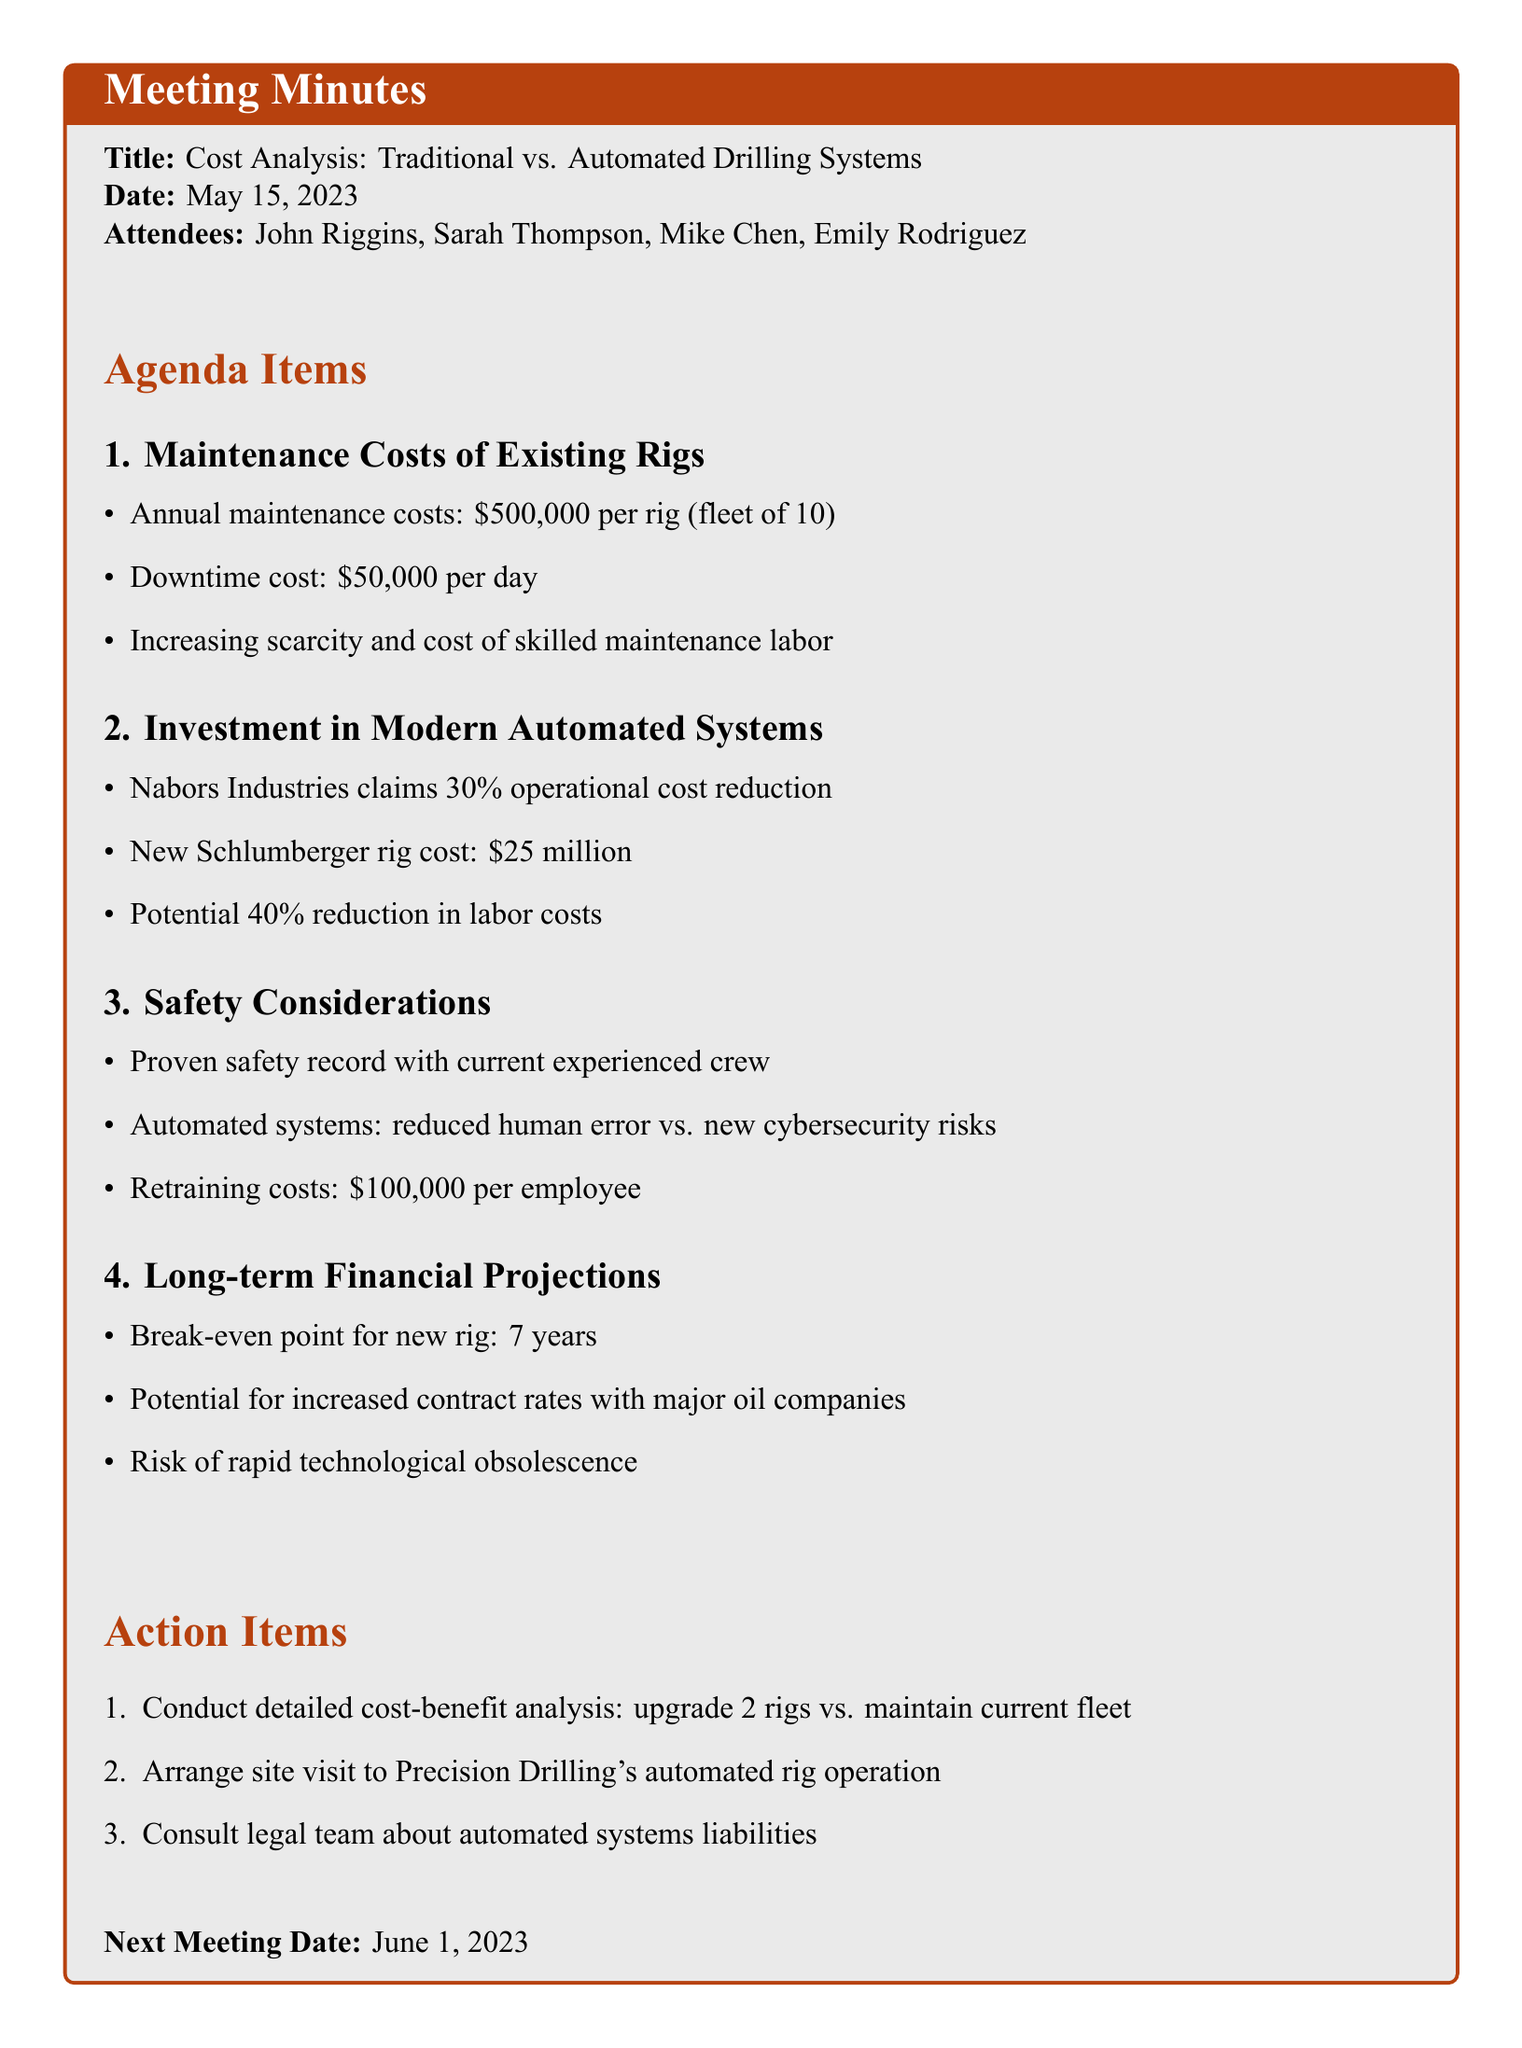What is the title of the meeting? The title of the meeting is clearly stated at the beginning of the document as "Cost Analysis: Traditional vs. Automated Drilling Systems".
Answer: Cost Analysis: Traditional vs. Automated Drilling Systems Who is the financial analyst in attendance? The document lists the attendees, including Sarah Thompson, who is identified as the financial analyst.
Answer: Sarah Thompson What is the average annual maintenance cost for each rig? The document specifies that the average annual maintenance cost for the rigs is $500,000 per rig.
Answer: $500,000 What is the estimated retraining cost per employee for automated systems? The retraining costs for existing staff to operate new systems is noted to be $100,000 per employee in the document.
Answer: $100,000 What potential reduction in labor costs is associated with automated systems? The document claims that automated systems can potentially reduce labor costs by 40%.
Answer: 40% How many years is the break-even point for investing in a new automated rig? The break-even point for investing in a new automated rig is estimated at 7 years according to financial projections in the document.
Answer: 7 years What urgent action item was suggested regarding the current fleet? The action item suggests conducting a detailed cost-benefit analysis of upgrading 2 rigs versus maintaining the current fleet, which is highlighted in the action items section.
Answer: Conduct detailed cost-benefit analysis What safety concern is raised regarding automated systems? A concern mentioned in the document regarding automated systems is the introduction of new cybersecurity risks, which affects operational safety.
Answer: Cybersecurity risks 